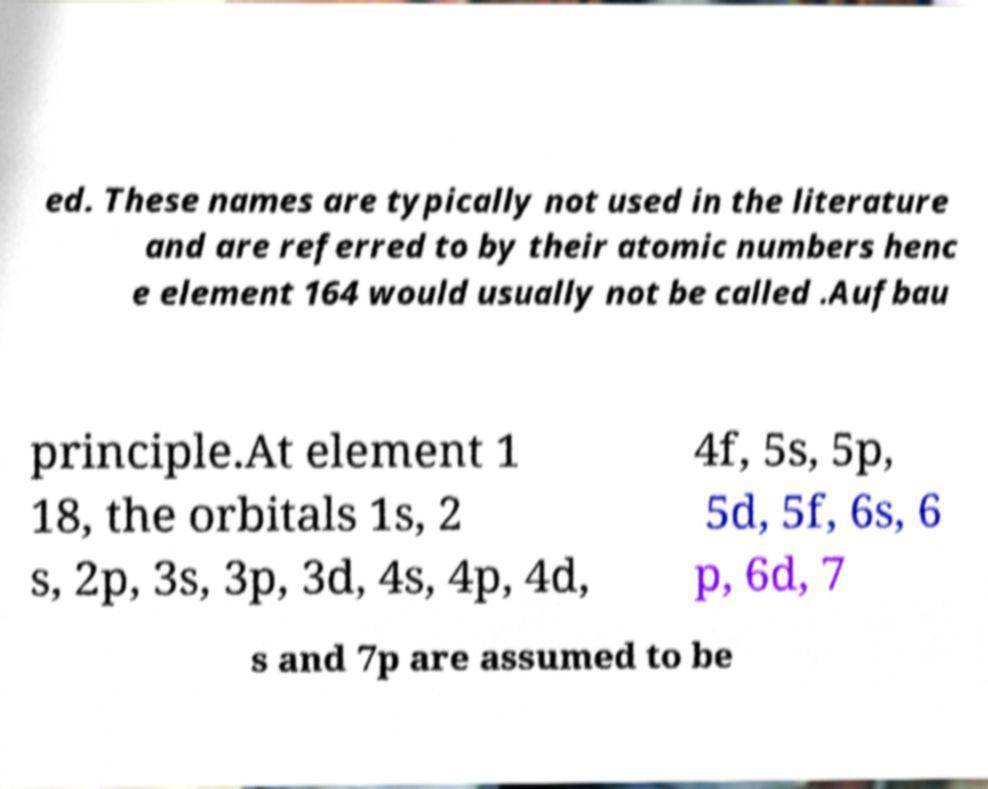There's text embedded in this image that I need extracted. Can you transcribe it verbatim? ed. These names are typically not used in the literature and are referred to by their atomic numbers henc e element 164 would usually not be called .Aufbau principle.At element 1 18, the orbitals 1s, 2 s, 2p, 3s, 3p, 3d, 4s, 4p, 4d, 4f, 5s, 5p, 5d, 5f, 6s, 6 p, 6d, 7 s and 7p are assumed to be 